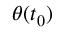Convert formula to latex. <formula><loc_0><loc_0><loc_500><loc_500>\theta ( t _ { 0 } )</formula> 